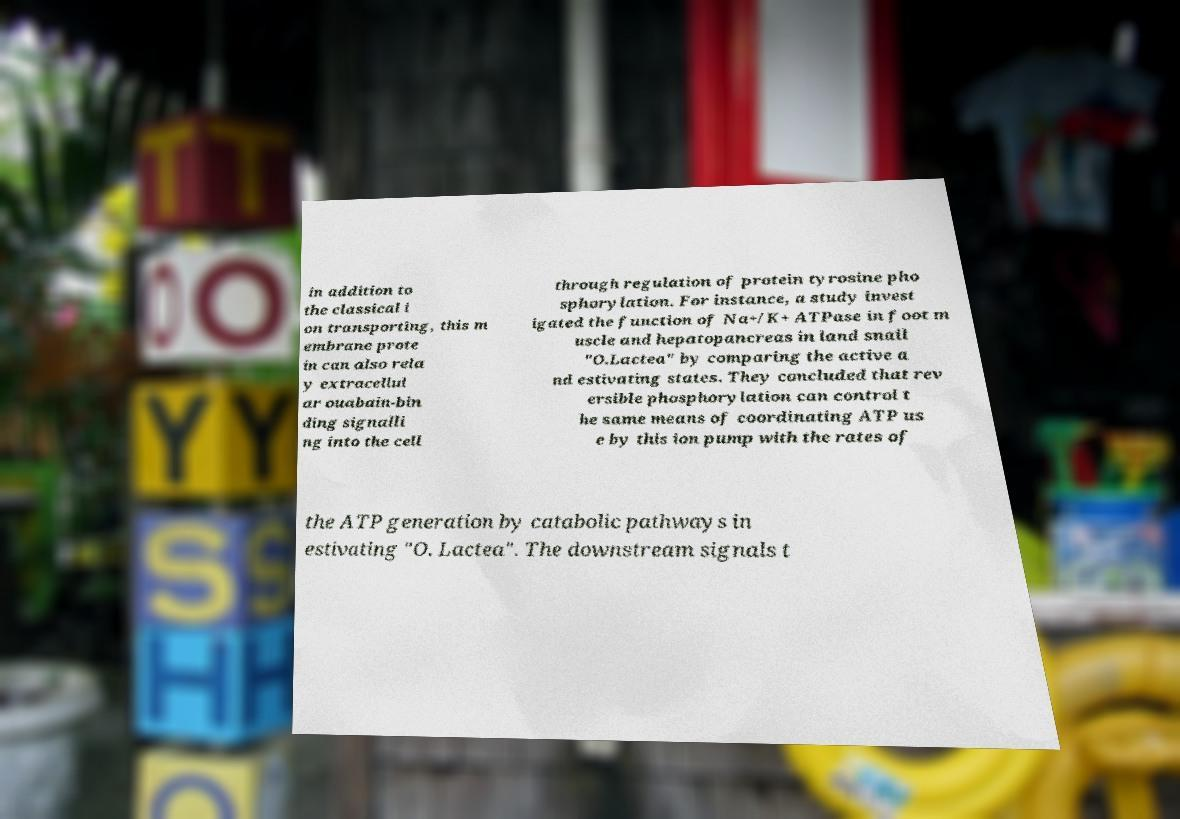Please read and relay the text visible in this image. What does it say? in addition to the classical i on transporting, this m embrane prote in can also rela y extracellul ar ouabain-bin ding signalli ng into the cell through regulation of protein tyrosine pho sphorylation. For instance, a study invest igated the function of Na+/K+ ATPase in foot m uscle and hepatopancreas in land snail "O.Lactea" by comparing the active a nd estivating states. They concluded that rev ersible phosphorylation can control t he same means of coordinating ATP us e by this ion pump with the rates of the ATP generation by catabolic pathways in estivating "O. Lactea". The downstream signals t 